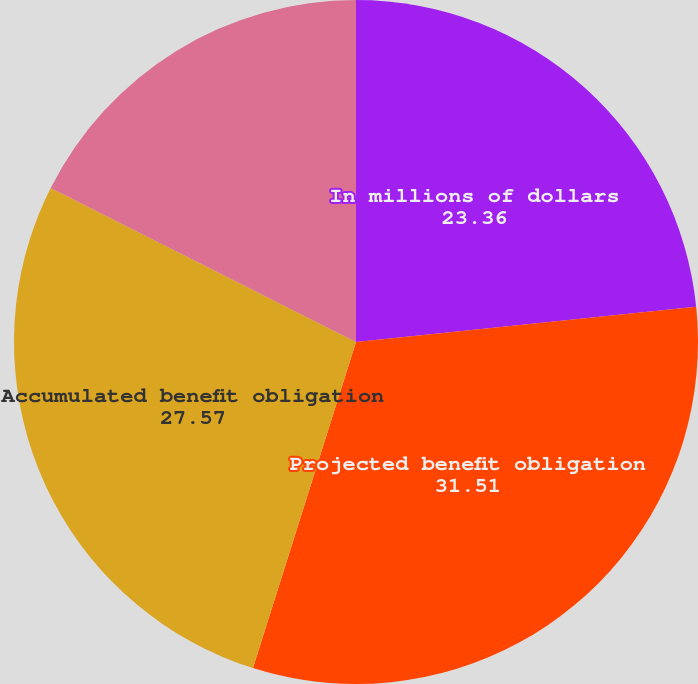Convert chart to OTSL. <chart><loc_0><loc_0><loc_500><loc_500><pie_chart><fcel>In millions of dollars<fcel>Projected benefit obligation<fcel>Accumulated benefit obligation<fcel>Fair value of plan assets<nl><fcel>23.36%<fcel>31.51%<fcel>27.57%<fcel>17.56%<nl></chart> 